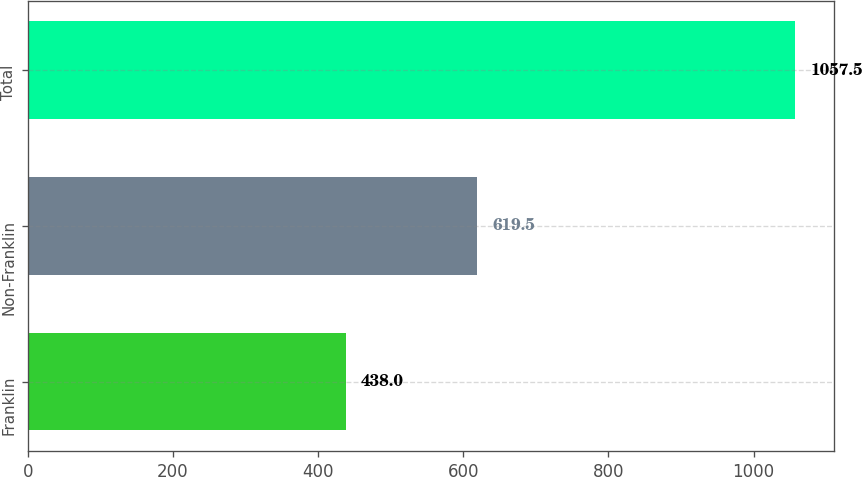<chart> <loc_0><loc_0><loc_500><loc_500><bar_chart><fcel>Franklin<fcel>Non-Franklin<fcel>Total<nl><fcel>438<fcel>619.5<fcel>1057.5<nl></chart> 